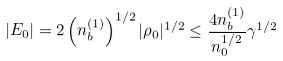<formula> <loc_0><loc_0><loc_500><loc_500>| E _ { 0 } | = 2 \left ( n _ { b } ^ { ( 1 ) } \right ) ^ { 1 / 2 } | \rho _ { 0 } | ^ { 1 / 2 } \leq \frac { 4 n _ { b } ^ { ( 1 ) } } { n _ { 0 } ^ { 1 / 2 } } \gamma ^ { 1 / 2 }</formula> 